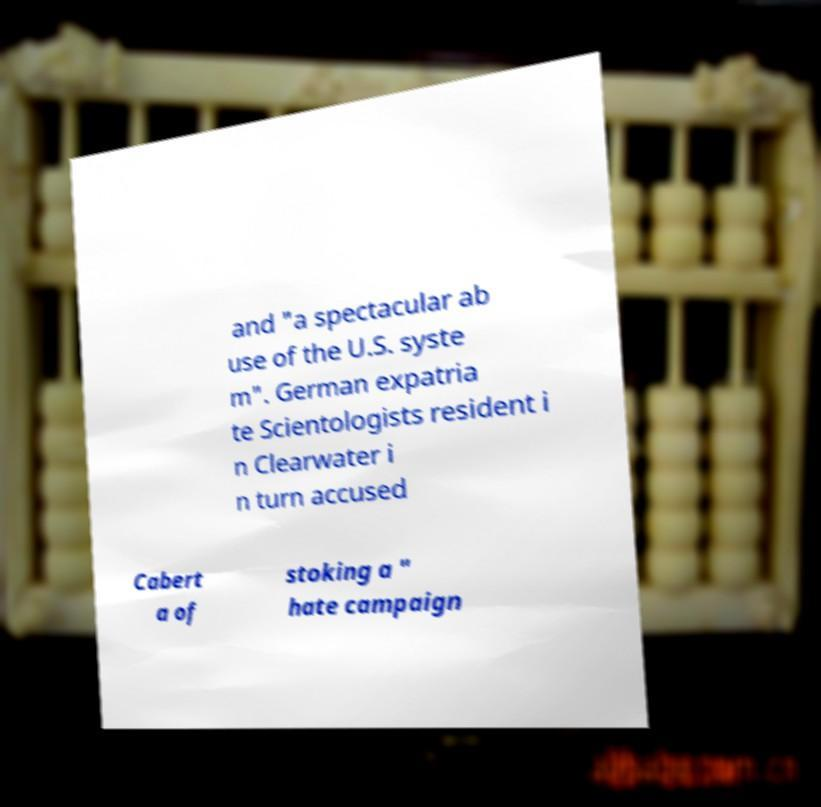Could you assist in decoding the text presented in this image and type it out clearly? and "a spectacular ab use of the U.S. syste m". German expatria te Scientologists resident i n Clearwater i n turn accused Cabert a of stoking a " hate campaign 